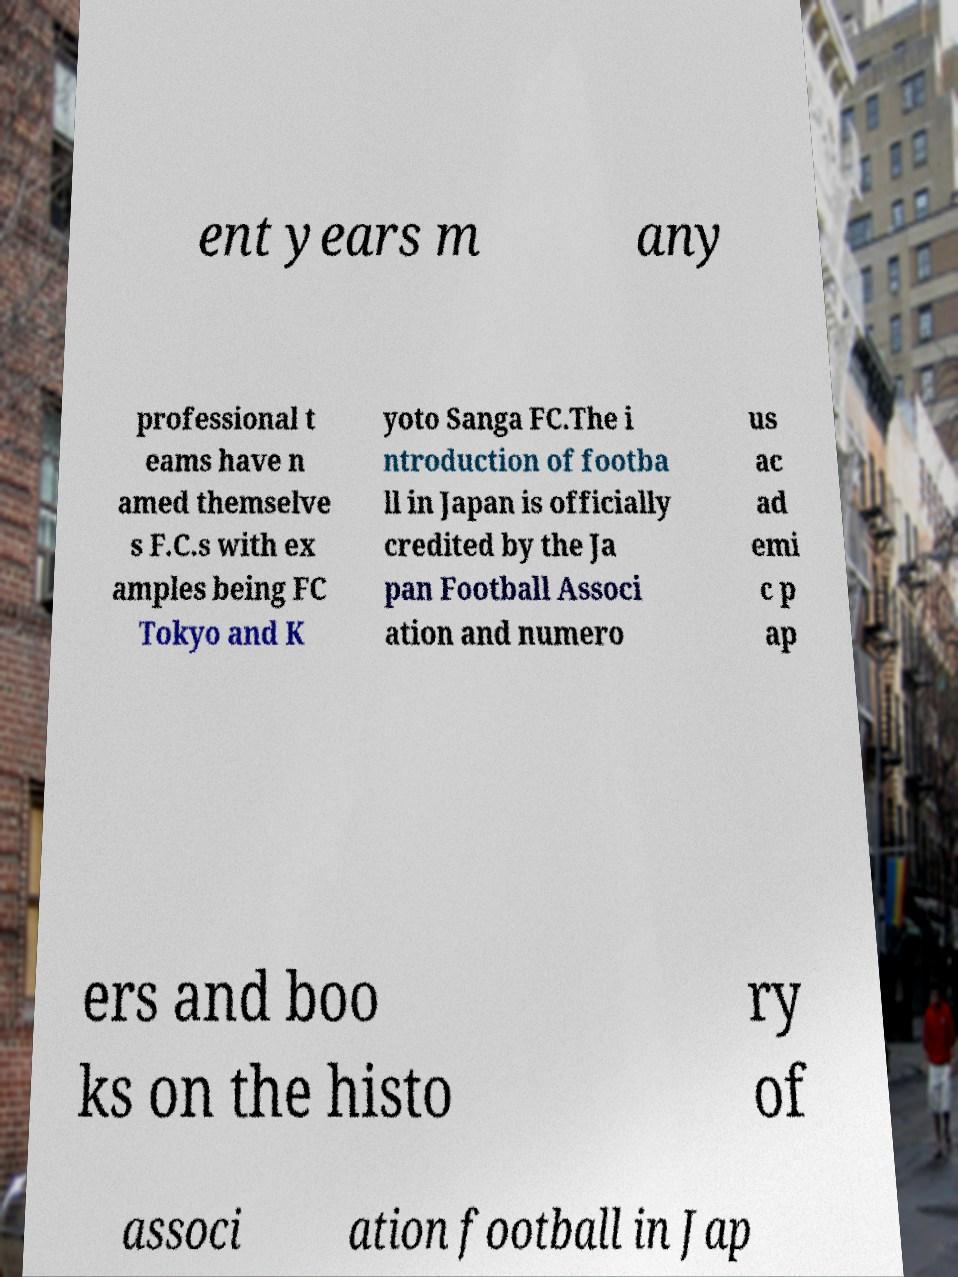Please read and relay the text visible in this image. What does it say? ent years m any professional t eams have n amed themselve s F.C.s with ex amples being FC Tokyo and K yoto Sanga FC.The i ntroduction of footba ll in Japan is officially credited by the Ja pan Football Associ ation and numero us ac ad emi c p ap ers and boo ks on the histo ry of associ ation football in Jap 